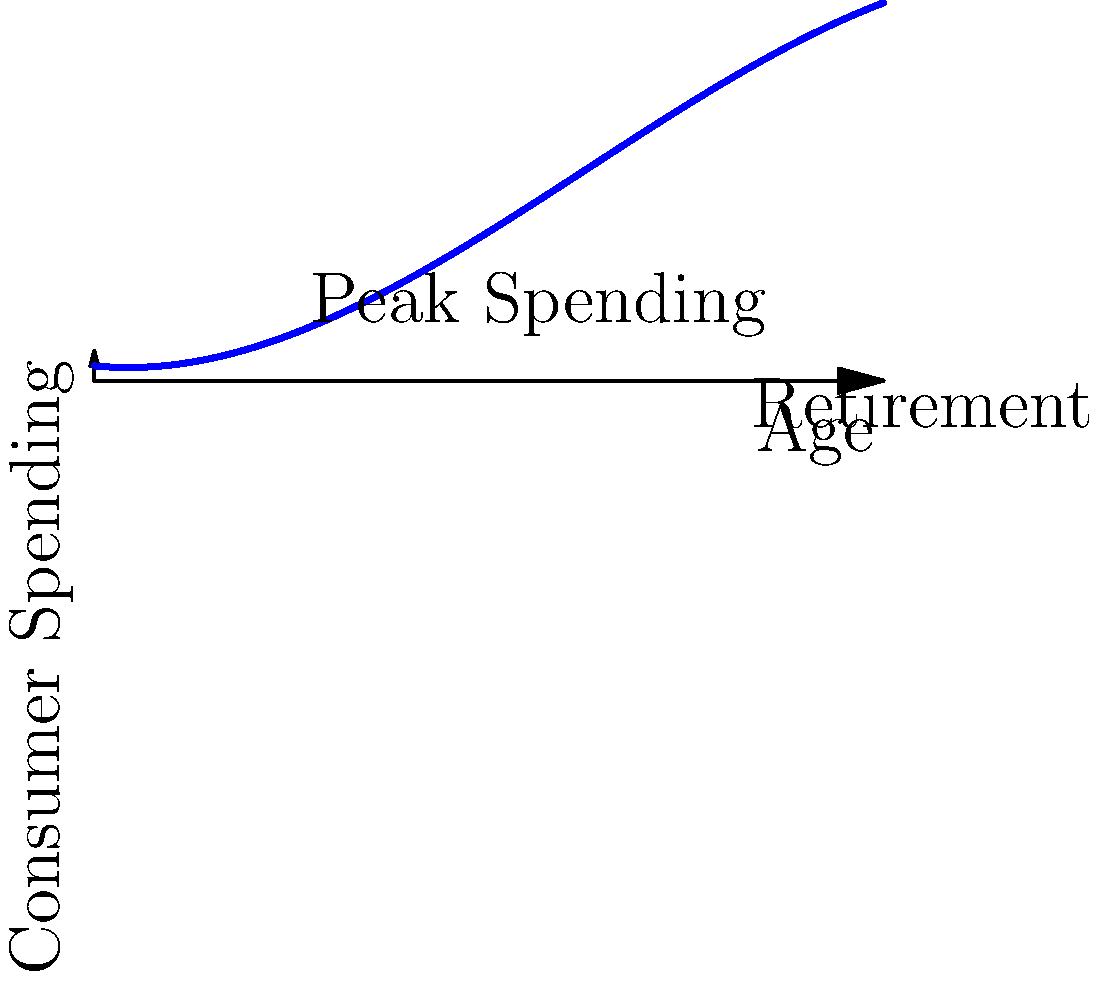Based on the demographic spending curve shown, which aligns with Harry Dent's theories on consumer spending patterns, at approximately what age does consumer spending peak, and how might this impact investment strategies in consumer-focused sectors? To answer this question, we need to analyze the polynomial curve representing consumer spending patterns across different age groups:

1. The curve starts low in the early years, representing lower spending by young individuals.

2. It rises steadily through early adulthood and middle age, indicating increased spending as income and family responsibilities grow.

3. The curve reaches its peak around age 45-50, which aligns with Harry Dent's theory that consumer spending typically peaks when individuals are in their mid-40s to early 50s.

4. After the peak, there's a gradual decline, representing reduced spending in later years and retirement.

5. The peak at age 45-50 is significant because it represents the highest point of consumer spending, which Dent argues drives economic cycles.

6. For investment strategies:
   a) Sectors catering to peak spenders (ages 45-50) might be more attractive in the short to medium term.
   b) As the population ages, sectors serving older consumers may become more lucrative.
   c) The gradual decline after the peak suggests a potential shift in investment focus from growth to value stocks in consumer sectors.

7. It's crucial to consider the current demographic distribution and future projections when applying this model to investment decisions.
Answer: Peak spending occurs around age 45-50; invest in sectors catering to this age group short-term, but prepare for a shift towards older consumer markets long-term. 